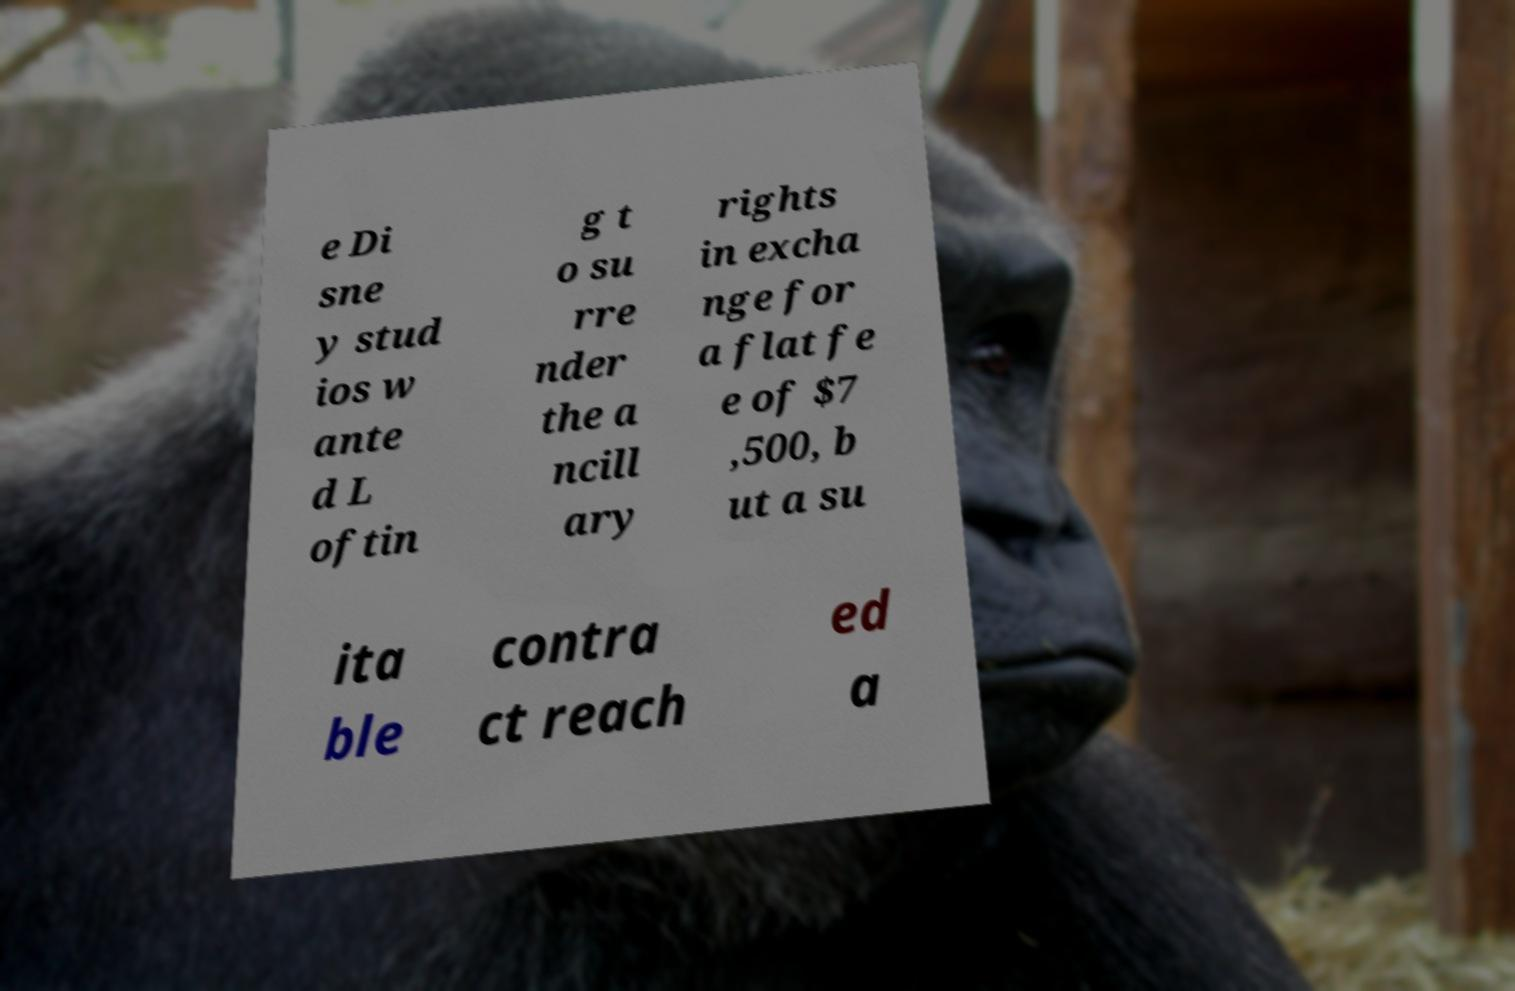I need the written content from this picture converted into text. Can you do that? e Di sne y stud ios w ante d L oftin g t o su rre nder the a ncill ary rights in excha nge for a flat fe e of $7 ,500, b ut a su ita ble contra ct reach ed a 